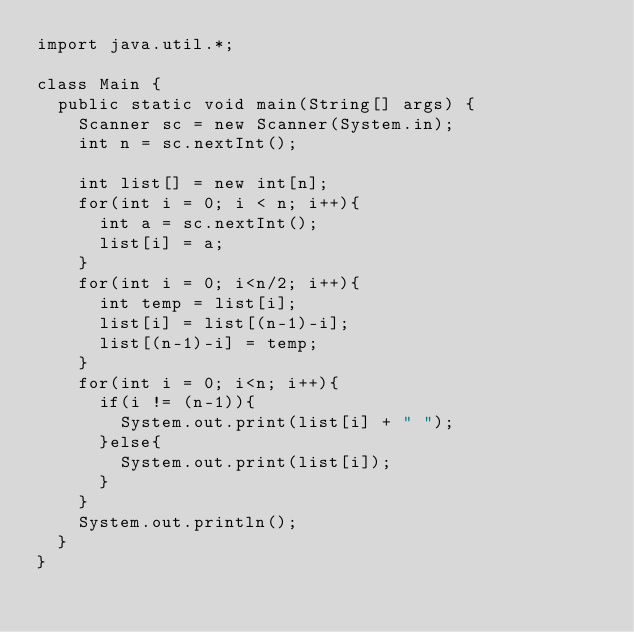<code> <loc_0><loc_0><loc_500><loc_500><_Java_>import java.util.*;

class Main {
  public static void main(String[] args) {
    Scanner sc = new Scanner(System.in);
    int n = sc.nextInt();

    int list[] = new int[n];
    for(int i = 0; i < n; i++){
      int a = sc.nextInt();
      list[i] = a;
    }
    for(int i = 0; i<n/2; i++){
      int temp = list[i];
      list[i] = list[(n-1)-i];
      list[(n-1)-i] = temp;
    }
    for(int i = 0; i<n; i++){
      if(i != (n-1)){
        System.out.print(list[i] + " ");
      }else{
        System.out.print(list[i]);
      }
    }
    System.out.println();
  }
}
</code> 